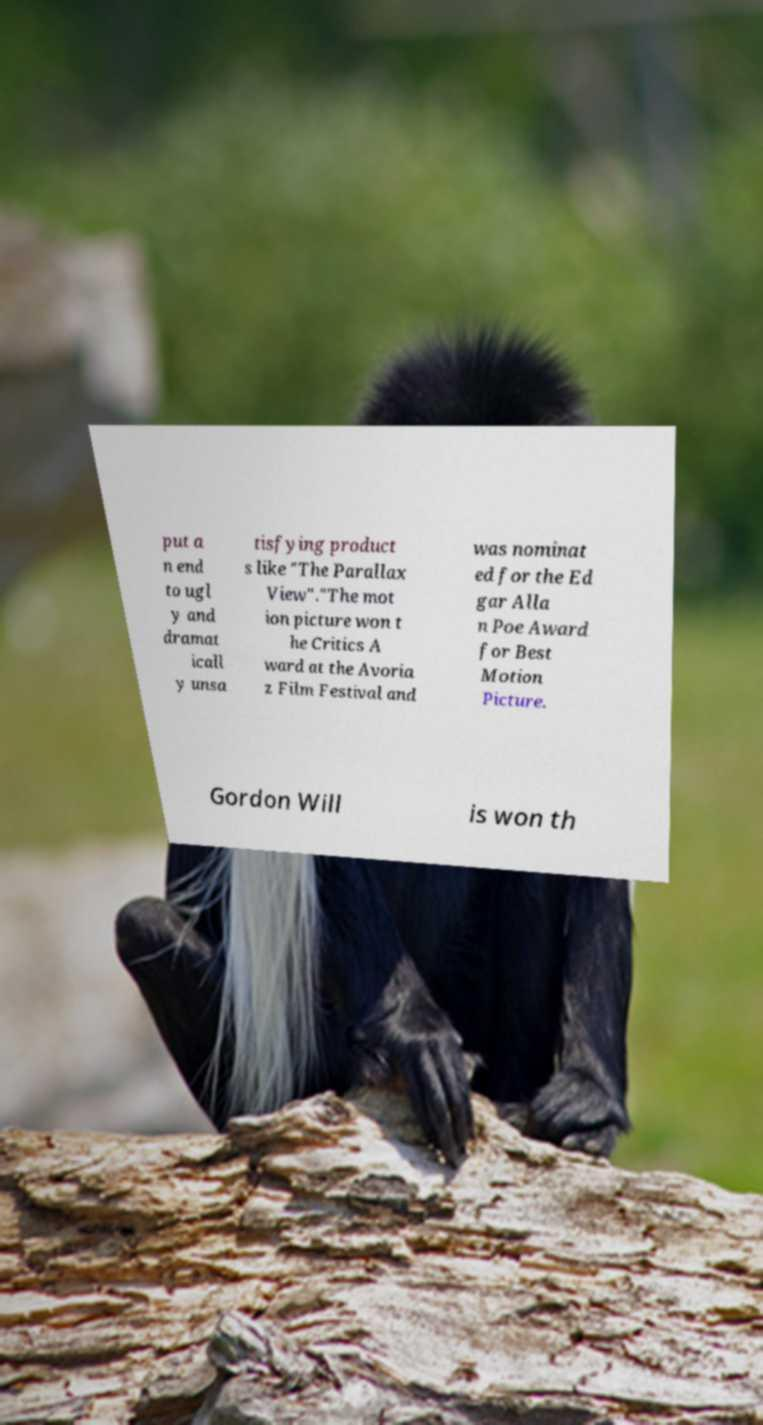For documentation purposes, I need the text within this image transcribed. Could you provide that? put a n end to ugl y and dramat icall y unsa tisfying product s like "The Parallax View"."The mot ion picture won t he Critics A ward at the Avoria z Film Festival and was nominat ed for the Ed gar Alla n Poe Award for Best Motion Picture. Gordon Will is won th 